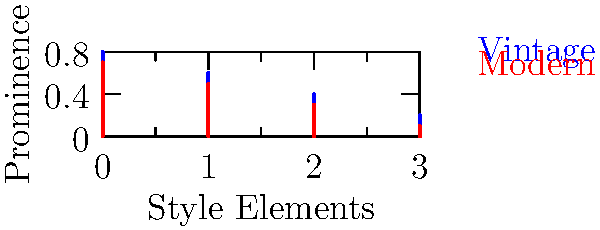As a fashion designer, you're analyzing the similarity between vintage and modern styles for your collection. Given the prominence vectors for vintage style $\mathbf{v} = [0.8, 0.6, 0.4, 0.2]$ and modern style $\mathbf{m} = [0.7, 0.5, 0.3, 0.1]$, where each component represents the prominence of a specific style element (e.g., silhouette, fabric, color, accessories), calculate the cosine similarity between these styles using the dot product. Round your answer to two decimal places. To calculate the cosine similarity between two vectors using the dot product, we follow these steps:

1) The formula for cosine similarity is:

   $$\cos \theta = \frac{\mathbf{v} \cdot \mathbf{m}}{|\mathbf{v}||\mathbf{m}|}$$

2) Calculate the dot product $\mathbf{v} \cdot \mathbf{m}$:
   $$(0.8 \times 0.7) + (0.6 \times 0.5) + (0.4 \times 0.3) + (0.2 \times 0.1) = 0.56 + 0.30 + 0.12 + 0.02 = 1.00$$

3) Calculate $|\mathbf{v}|$:
   $$|\mathbf{v}| = \sqrt{0.8^2 + 0.6^2 + 0.4^2 + 0.2^2} = \sqrt{0.64 + 0.36 + 0.16 + 0.04} = \sqrt{1.20} \approx 1.0954$$

4) Calculate $|\mathbf{m}|$:
   $$|\mathbf{m}| = \sqrt{0.7^2 + 0.5^2 + 0.3^2 + 0.1^2} = \sqrt{0.49 + 0.25 + 0.09 + 0.01} = \sqrt{0.84} \approx 0.9165$$

5) Apply the formula:
   $$\cos \theta = \frac{1.00}{1.0954 \times 0.9165} \approx 0.9959$$

6) Round to two decimal places: 1.00

This result indicates a very high similarity between the vintage and modern styles in your collection.
Answer: 1.00 